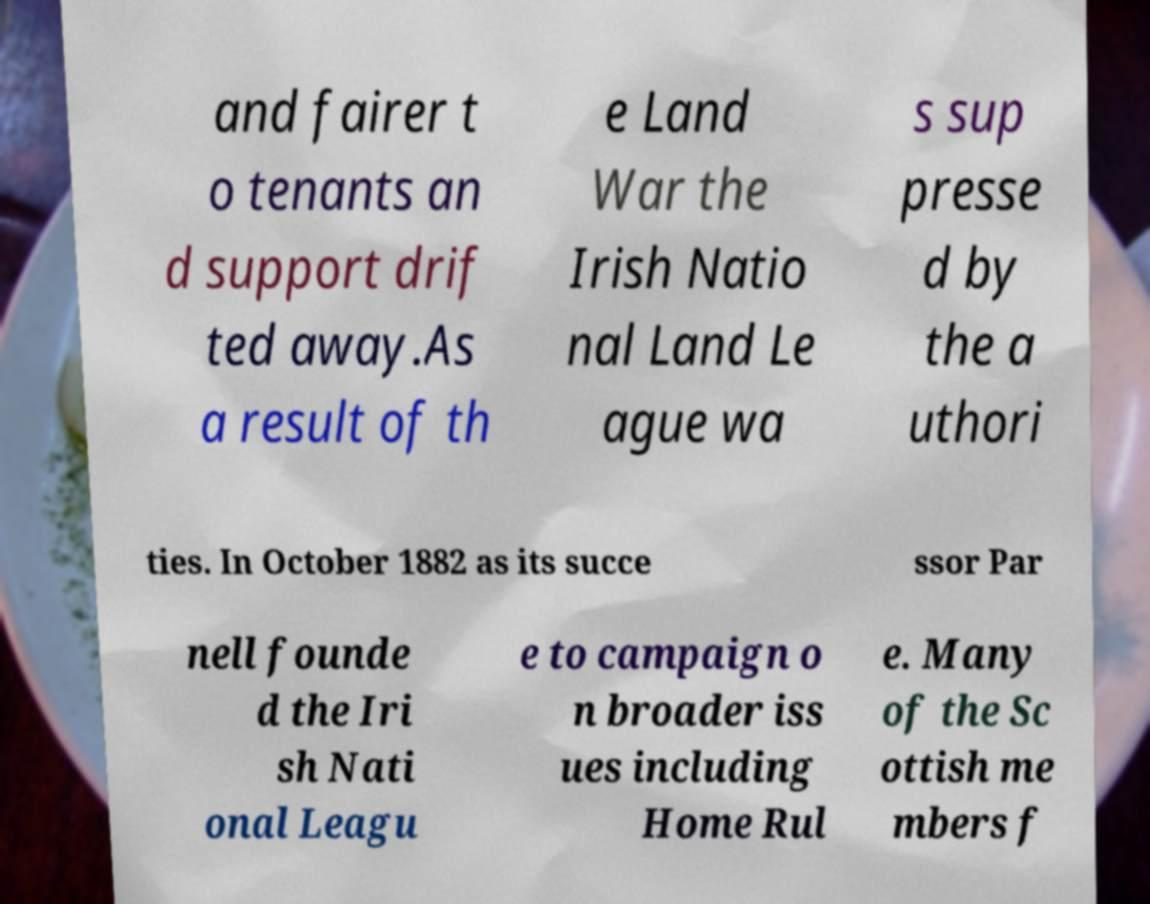What messages or text are displayed in this image? I need them in a readable, typed format. and fairer t o tenants an d support drif ted away.As a result of th e Land War the Irish Natio nal Land Le ague wa s sup presse d by the a uthori ties. In October 1882 as its succe ssor Par nell founde d the Iri sh Nati onal Leagu e to campaign o n broader iss ues including Home Rul e. Many of the Sc ottish me mbers f 